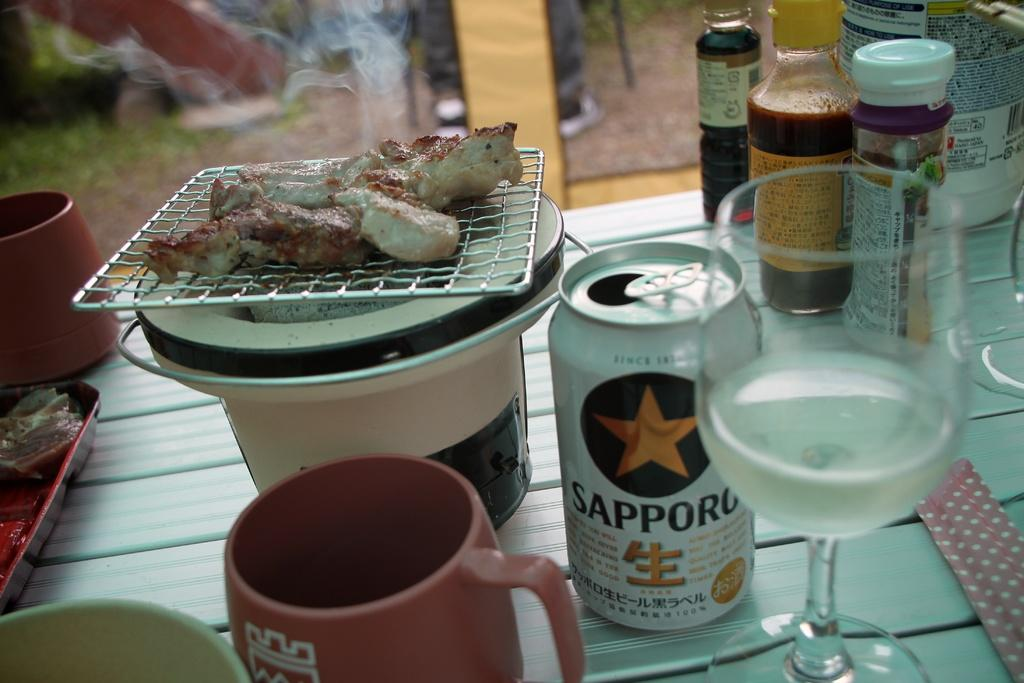<image>
Offer a succinct explanation of the picture presented. Barbecued chicken is on a table next to an open can of Sapporo. 